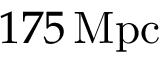Convert formula to latex. <formula><loc_0><loc_0><loc_500><loc_500>1 7 5 \, { M p c }</formula> 